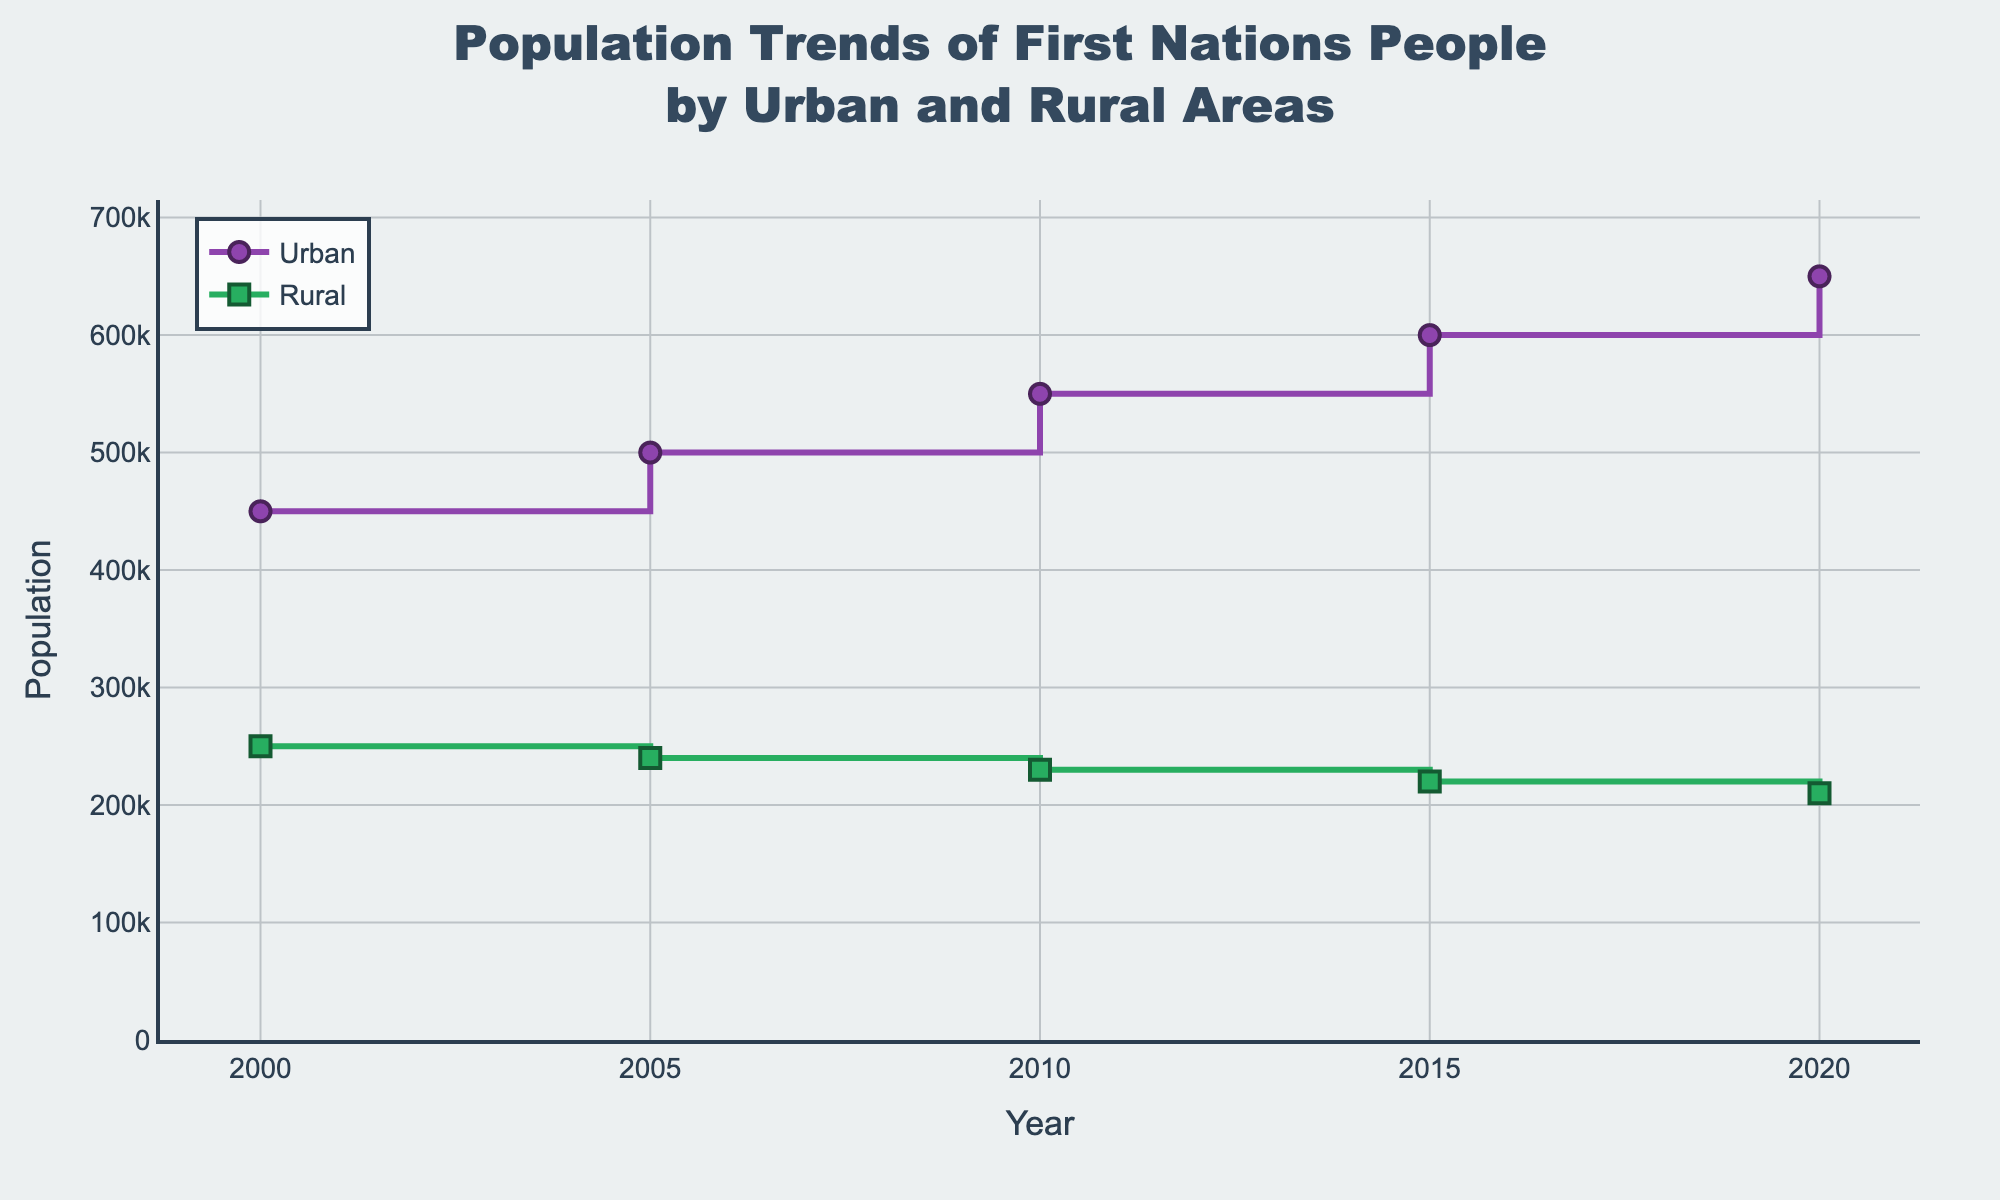What's the title of the plot? The title of the plot is usually prominently displayed at the top of the figure. It serves as a summary of what the figure represents. In this case, the title is "Population Trends of First Nations People by Urban and Rural Areas".
Answer: Population Trends of First Nations People by Urban and Rural Areas What is the y-axis representing? The y-axis typically shows what is being measured. By looking at the y-axis label, we can see that it represents "Population".
Answer: Population How many data points are there for Urban areas? By counting the markers in the Urban data series, we see that there are data points for the years 2000, 2005, 2010, 2015, and 2020, which makes a total of 5 data points.
Answer: 5 What is the population difference between Urban and Rural areas in 2020? To find the difference, we need to look at the population values for both Urban and Rural areas in 2020. The Urban population is 650,000 and the Rural population is 210,000. The difference is 650,000 - 210,000.
Answer: 440,000 Which area shows a declining population trend from 2000 to 2020? By observing the lines, the Rural area's population trend shows a decline over the years, while the Urban area's population increases.
Answer: Rural What is the population trend in Urban areas from 2000 to 2020? The line for Urban areas shows an increasing trend from 450,000 in 2000 to 650,000 in 2020, indicating a steady rise.
Answer: Increasing By how much did the Rural area population decrease from 2000 to 2020? The initial rural population in 2000 was 250,000 and by 2020, it was 210,000. The decrease can be calculated as 250,000 - 210,000.
Answer: 40,000 What is the average population of First Nations people living in Urban areas over the period? To find the average, sum up the Urban population values for each year (450,000 + 500,000 + 550,000 + 600,000 + 650,000) and divide by the number of data points, which is 5. The sum is 2,750,000, and the average is 2,750,000 / 5.
Answer: 550,000 Which year has the smallest population difference between Urban and Rural areas? Calculate the differences for each year:
2000: 450,000 - 250,000 = 200,000
2005: 500,000 - 240,000 = 260,000
2010: 550,000 - 230,000 = 320,000
2015: 600,000 - 220,000 = 380,000
2020: 650,000 - 210,000 = 440,000
The year 2000 has the smallest population difference at 200,000.
Answer: 2000 